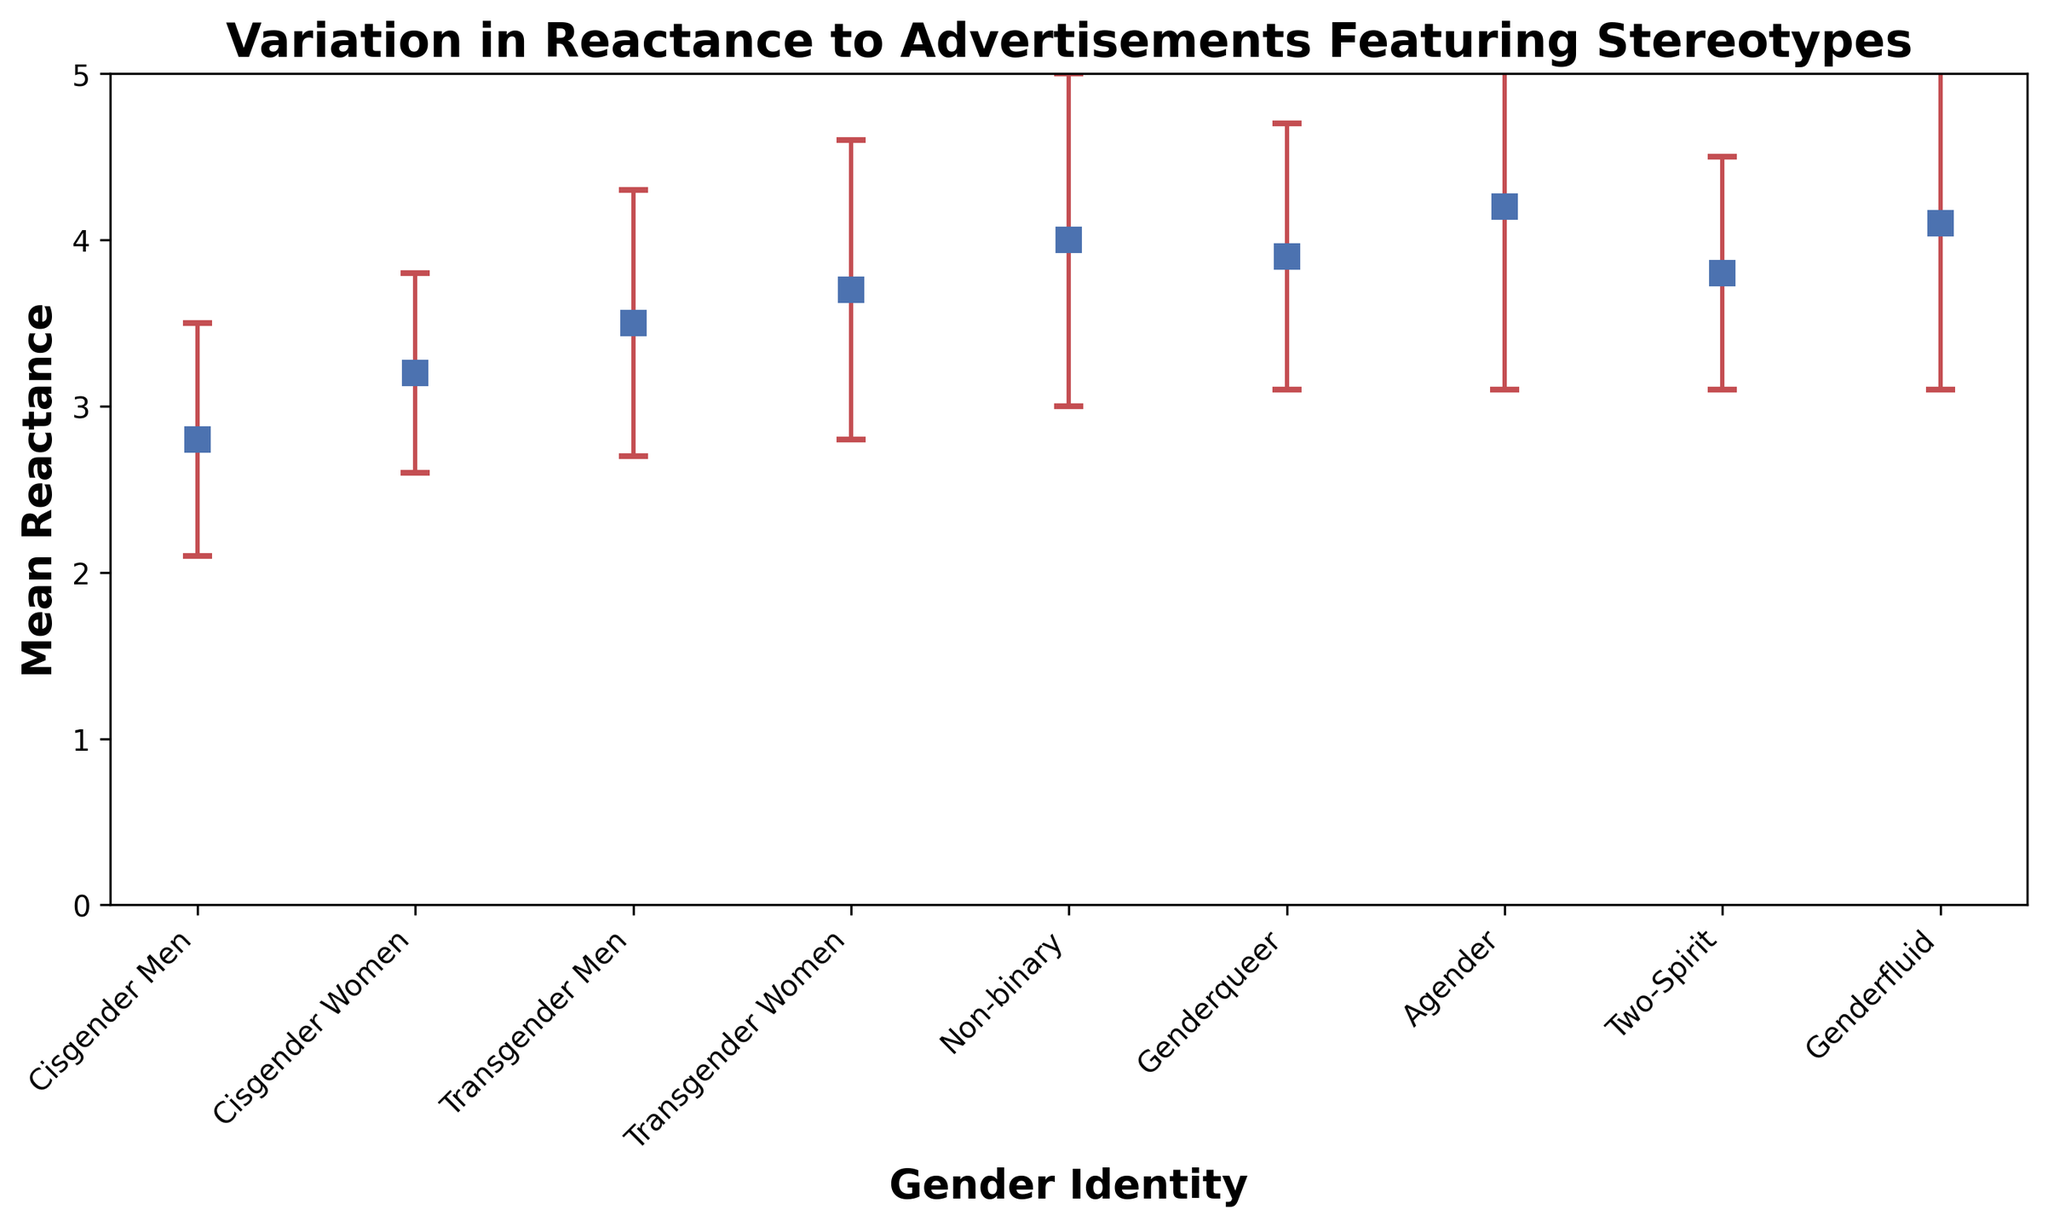What is the mean reactance for Cisgender Women, and how does it compare to Cisgender Men? First, identify the mean reactance values from the plot for Cisgender Women and Cisgender Men. For Cisgender Women, it is 3.2, and for Cisgender Men, it is 2.8. Compare these values to determine that Cisgender Women's mean reactance is higher.
Answer: Cisgender Women: 3.2, Cisgender Men: 2.8 What is the difference in mean reactance between Transgender Women and Transgender Men? From the plot, determine the mean reactance for Transgender Women (3.7) and Transgender Men (3.5). Subtract the mean reactance of Transgender Men from Transgender Women (3.7 - 3.5 = 0.2) to find the difference.
Answer: 0.2 Which gender identity group shows the highest mean reactance to advertisements featuring stereotypes? Review the plot to find the gender identity with the tallest marker point representing the mean reactance. Non-binary shows the highest mean reactance of 4.0.
Answer: Non-binary Which gender identity group has the largest variation in mean reactance, as indicated by the error bars? Examine the error bars (red lines) attached to each marker in the plot. Agender has the largest error bar, indicating the highest standard deviation (1.1).
Answer: Agender Compute the average mean reactance of all gender identity groups. Add the mean reactance values for all groups: (2.8 + 3.2 + 3.5 + 3.7 + 4.0 + 3.9 + 4.2 + 3.8 + 4.1) = 33.2. Then, divide by the number of groups, which is 9. So, 33.2 / 9 ≈ 3.69.
Answer: 3.69 Which gender identity group is closest to the overall average mean reactance? Calculate the overall average mean reactance (3.69). Identify the mean reactance values from the plot and find the closest match. Genderqueer, with a mean reactance of 3.9, is closest.
Answer: Genderqueer By how much does the mean reactance of Genderqueer individuals differ from Two-Spirit individuals? Locate the mean reactance values from the plot for Genderqueer (3.9) and Two-Spirit (3.8). Subtract the mean reactance of Two-Spirit from Genderqueer (3.9 - 3.8 = 0.1).
Answer: 0.1 Which group has the smallest error bar, indicating the least variation in mean reactance? Review the plot for the shortest error bar. Cisgender Women have the smallest error bar (standard deviation 0.6).
Answer: Cisgender Women Are any groups’ mean reactance exactly equal? Check the plot to compare the mean reactance values visually. No groups have exactly equal mean reactance values; they are all different.
Answer: No 